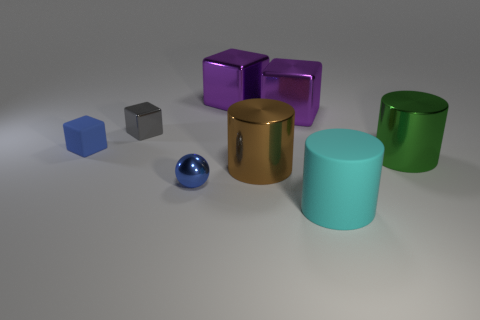Are there more metal cylinders behind the small matte object than big brown shiny cylinders that are left of the small blue metallic sphere? There appears to be only one metal cylinder, which is the large brown shiny one to the left of the small blue metallic sphere. There are no other cylinders behind the small matte object that fit the description of metal cylinders. Therefore, the answer to your question is that there are not more metal cylinders behind the small matte object than big brown shiny cylinders beside the small blue metallic sphere; in fact, there's just one cylinder in view. 